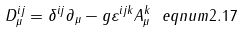Convert formula to latex. <formula><loc_0><loc_0><loc_500><loc_500>D _ { \mu } ^ { i j } = \delta ^ { i j } \partial _ { \mu } - g \varepsilon ^ { i j k } A _ { \mu } ^ { k } \ e q n u m { 2 . 1 7 }</formula> 